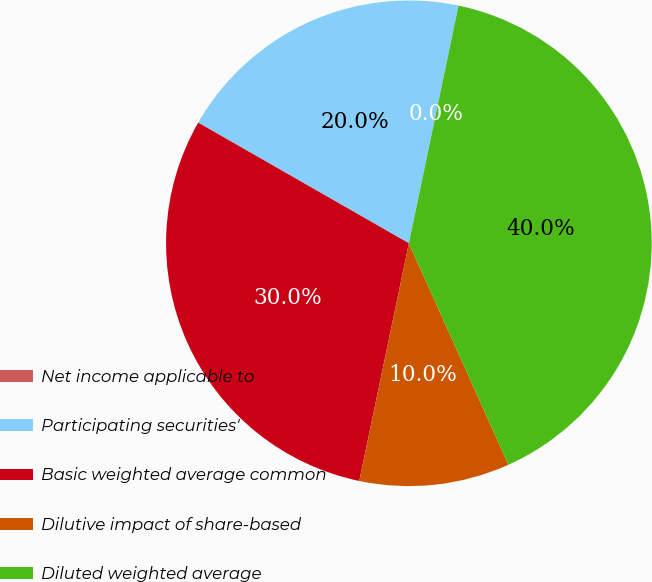Convert chart to OTSL. <chart><loc_0><loc_0><loc_500><loc_500><pie_chart><fcel>Net income applicable to<fcel>Participating securities'<fcel>Basic weighted average common<fcel>Dilutive impact of share-based<fcel>Diluted weighted average<nl><fcel>0.0%<fcel>20.0%<fcel>30.0%<fcel>10.0%<fcel>40.0%<nl></chart> 